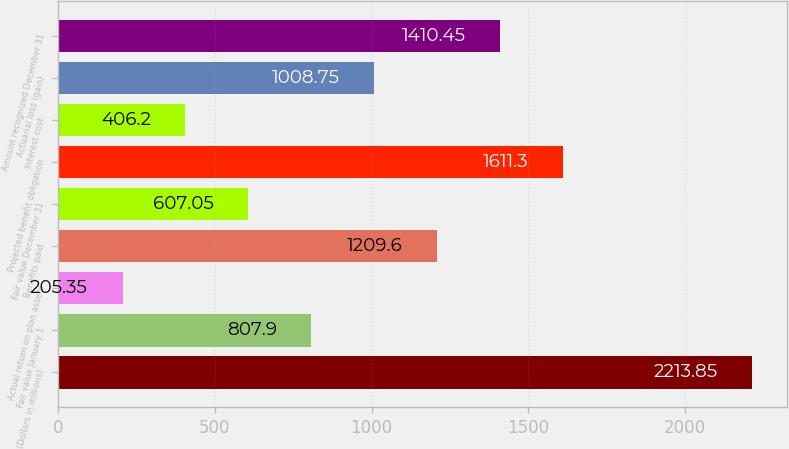Convert chart. <chart><loc_0><loc_0><loc_500><loc_500><bar_chart><fcel>(Dollars in millions)<fcel>Fair value January 1<fcel>Actual return on plan assets<fcel>Benefits paid<fcel>Fair value December 31<fcel>Projected benefit obligation<fcel>Interest cost<fcel>Actuarial loss (gain)<fcel>Amount recognized December 31<nl><fcel>2213.85<fcel>807.9<fcel>205.35<fcel>1209.6<fcel>607.05<fcel>1611.3<fcel>406.2<fcel>1008.75<fcel>1410.45<nl></chart> 